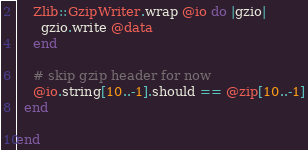<code> <loc_0><loc_0><loc_500><loc_500><_Ruby_>    Zlib::GzipWriter.wrap @io do |gzio|
      gzio.write @data
    end

    # skip gzip header for now
    @io.string[10..-1].should == @zip[10..-1]
  end

end

</code> 